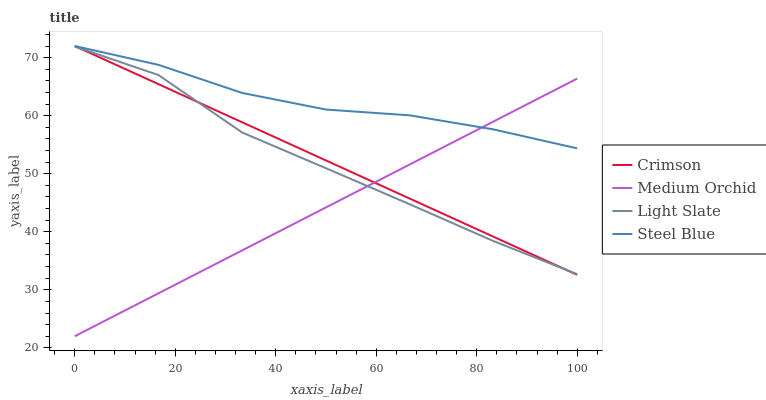Does Medium Orchid have the minimum area under the curve?
Answer yes or no. Yes. Does Steel Blue have the maximum area under the curve?
Answer yes or no. Yes. Does Light Slate have the minimum area under the curve?
Answer yes or no. No. Does Light Slate have the maximum area under the curve?
Answer yes or no. No. Is Medium Orchid the smoothest?
Answer yes or no. Yes. Is Light Slate the roughest?
Answer yes or no. Yes. Is Light Slate the smoothest?
Answer yes or no. No. Is Medium Orchid the roughest?
Answer yes or no. No. Does Medium Orchid have the lowest value?
Answer yes or no. Yes. Does Light Slate have the lowest value?
Answer yes or no. No. Does Steel Blue have the highest value?
Answer yes or no. Yes. Does Light Slate have the highest value?
Answer yes or no. No. Is Light Slate less than Steel Blue?
Answer yes or no. Yes. Is Steel Blue greater than Light Slate?
Answer yes or no. Yes. Does Medium Orchid intersect Light Slate?
Answer yes or no. Yes. Is Medium Orchid less than Light Slate?
Answer yes or no. No. Is Medium Orchid greater than Light Slate?
Answer yes or no. No. Does Light Slate intersect Steel Blue?
Answer yes or no. No. 